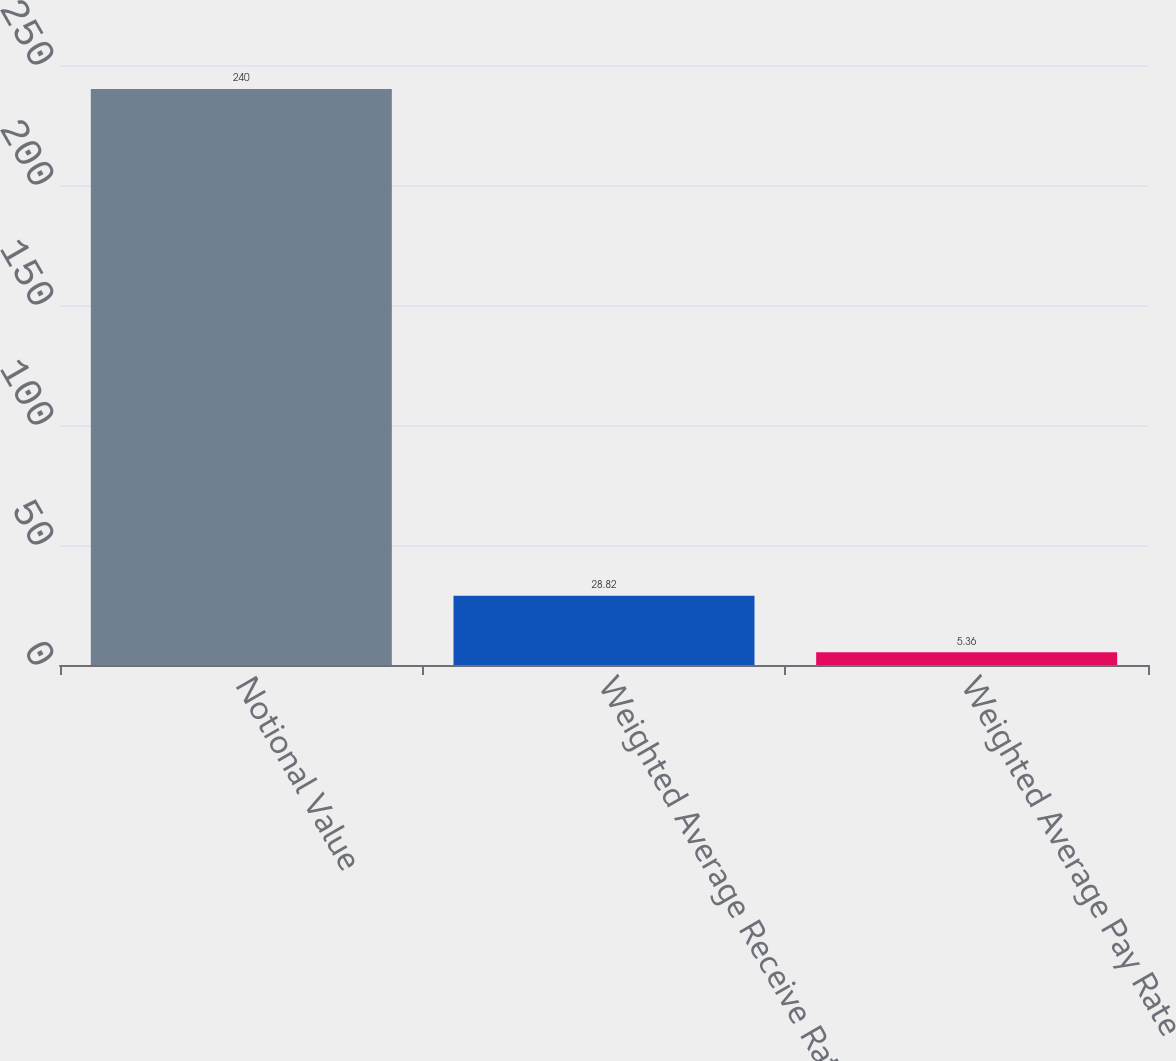<chart> <loc_0><loc_0><loc_500><loc_500><bar_chart><fcel>Notional Value<fcel>Weighted Average Receive Rate<fcel>Weighted Average Pay Rate<nl><fcel>240<fcel>28.82<fcel>5.36<nl></chart> 